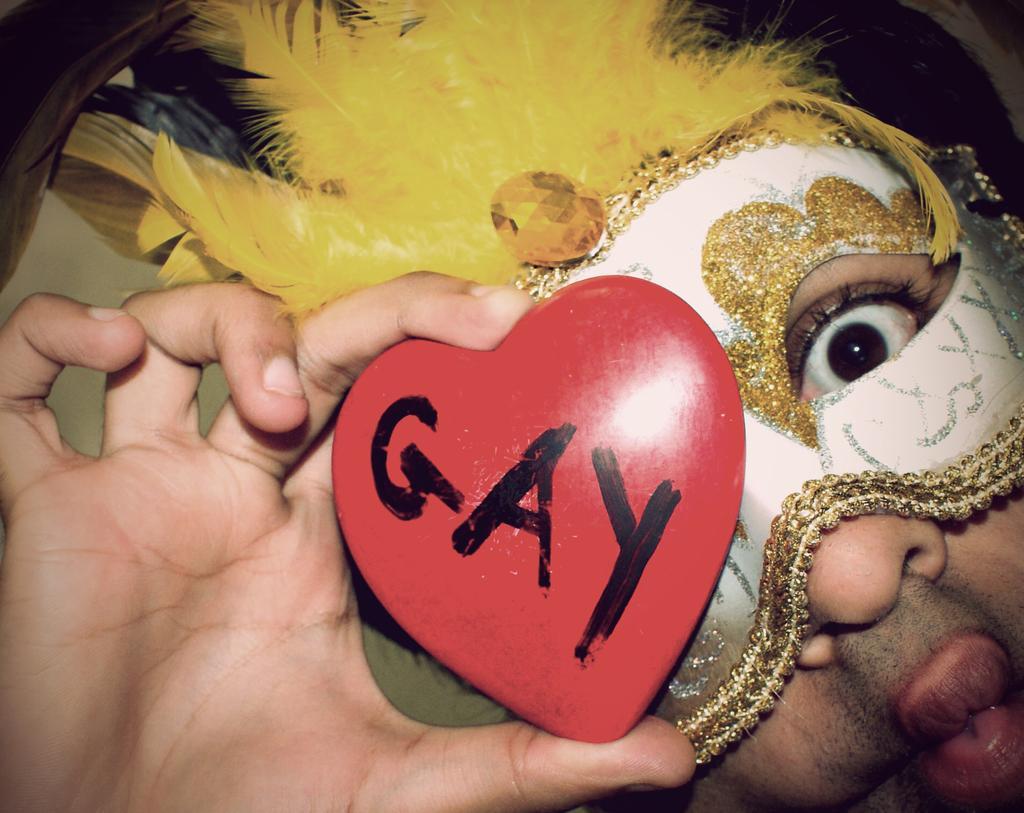Could you give a brief overview of what you see in this image? In this image there is a man holding a heart shaped object with a text on it in his hand. He is with a face mask and there are a few feathers on his head. 